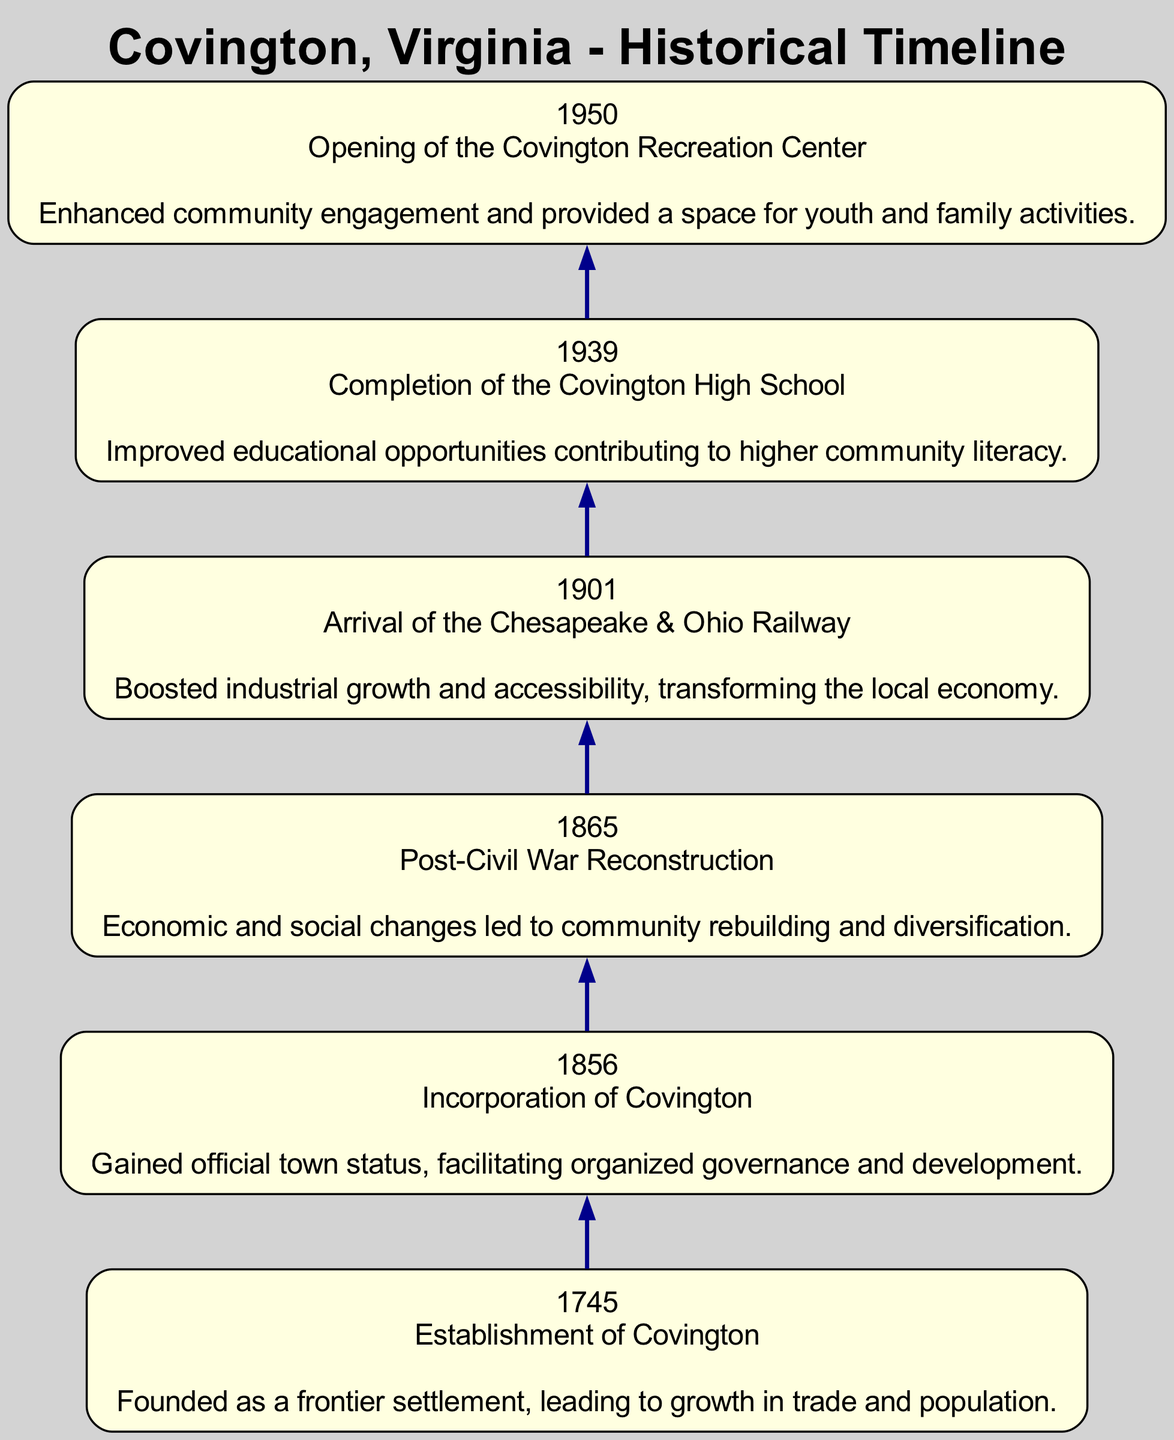What year was Covington established? The diagram shows that Covington was established in 1745, as indicated in the first node.
Answer: 1745 What event occurred in 1901? According to the diagram, the event that occurred in 1901 is the arrival of the Chesapeake & Ohio Railway, which is specified in the respective node.
Answer: Arrival of the Chesapeake & Ohio Railway How many key events are listed in the timeline? By counting the nodes in the diagram, there are a total of six key events that are described.
Answer: 6 What impact did the incorporation of Covington have? The diagram states that the incorporation of Covington facilitated organized governance and development, as shown in the node associated with that event in 1856.
Answer: Facilitated organized governance and development Which event marks a change after the Civil War? The diagram indicates that post-Civil War Reconstruction in 1865 marks a significant change, leading to economic and social changes in the community.
Answer: Post-Civil War Reconstruction What is the sequence of events from 1745 to 1950? Following the flow of the diagram from the earliest event in 1745 to the last event in 1950, you transition through the establishment, incorporation, post-Civil War changes, railway arrival, school completion, and recreation center opening.
Answer: Establishment, Incorporation, Post-Civil War Reconstruction, Arrival of the Railway, Completion of High School, Opening of Recreation Center What significant infrastructure arrived in Covington in 1901? The diagram specifically notes the arrival of the Chesapeake & Ohio Railway in 1901, indicating its importance as significant infrastructure.
Answer: Chesapeake & Ohio Railway What type of event occurred in 1939? The diagram clearly shows that the completion of Covington High School in 1939 is categorized as an educational event, enhancing community literacy.
Answer: Educational event What event led to community rebuilding? The timeline indicates that the post-Civil War Reconstruction in 1865 led to community rebuilding, as noted in its node.
Answer: Post-Civil War Reconstruction 